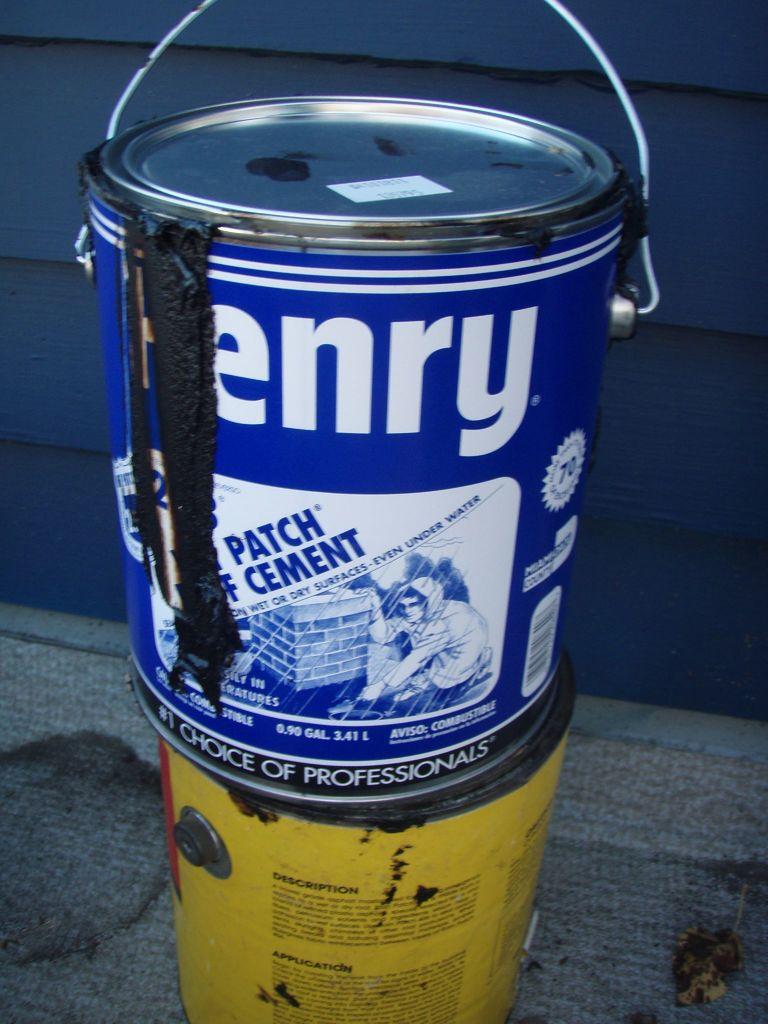What brand of paint is this?
Keep it short and to the point. Henry. Who chooses this kind of sealant?
Your answer should be compact. Professionals. 